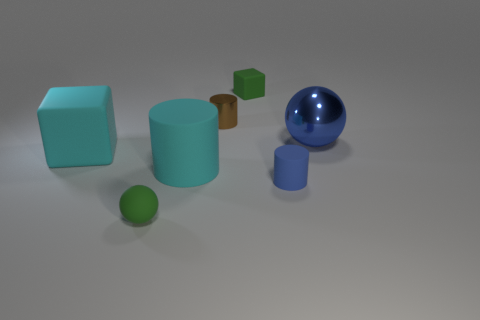Add 2 red rubber objects. How many objects exist? 9 Subtract all cylinders. How many objects are left? 4 Add 4 big cyan rubber cylinders. How many big cyan rubber cylinders are left? 5 Add 1 big brown shiny cylinders. How many big brown shiny cylinders exist? 1 Subtract 0 yellow cylinders. How many objects are left? 7 Subtract all tiny red cylinders. Subtract all blue rubber cylinders. How many objects are left? 6 